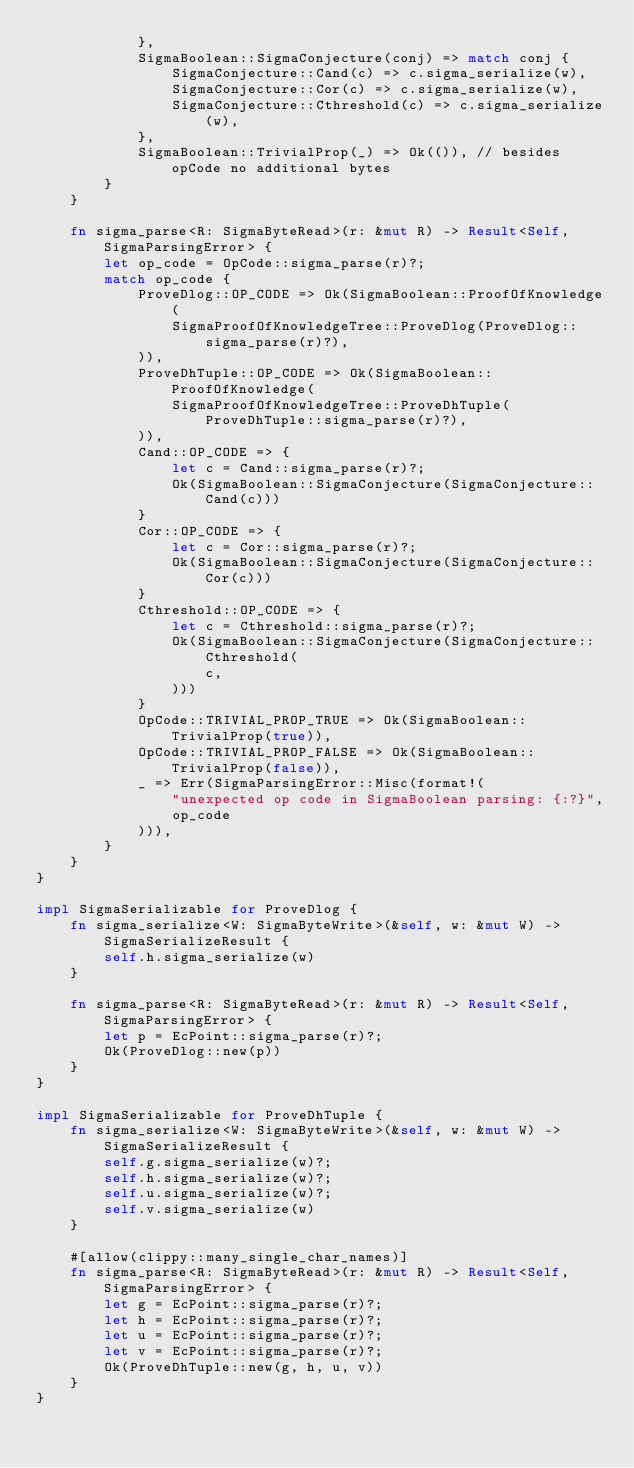<code> <loc_0><loc_0><loc_500><loc_500><_Rust_>            },
            SigmaBoolean::SigmaConjecture(conj) => match conj {
                SigmaConjecture::Cand(c) => c.sigma_serialize(w),
                SigmaConjecture::Cor(c) => c.sigma_serialize(w),
                SigmaConjecture::Cthreshold(c) => c.sigma_serialize(w),
            },
            SigmaBoolean::TrivialProp(_) => Ok(()), // besides opCode no additional bytes
        }
    }

    fn sigma_parse<R: SigmaByteRead>(r: &mut R) -> Result<Self, SigmaParsingError> {
        let op_code = OpCode::sigma_parse(r)?;
        match op_code {
            ProveDlog::OP_CODE => Ok(SigmaBoolean::ProofOfKnowledge(
                SigmaProofOfKnowledgeTree::ProveDlog(ProveDlog::sigma_parse(r)?),
            )),
            ProveDhTuple::OP_CODE => Ok(SigmaBoolean::ProofOfKnowledge(
                SigmaProofOfKnowledgeTree::ProveDhTuple(ProveDhTuple::sigma_parse(r)?),
            )),
            Cand::OP_CODE => {
                let c = Cand::sigma_parse(r)?;
                Ok(SigmaBoolean::SigmaConjecture(SigmaConjecture::Cand(c)))
            }
            Cor::OP_CODE => {
                let c = Cor::sigma_parse(r)?;
                Ok(SigmaBoolean::SigmaConjecture(SigmaConjecture::Cor(c)))
            }
            Cthreshold::OP_CODE => {
                let c = Cthreshold::sigma_parse(r)?;
                Ok(SigmaBoolean::SigmaConjecture(SigmaConjecture::Cthreshold(
                    c,
                )))
            }
            OpCode::TRIVIAL_PROP_TRUE => Ok(SigmaBoolean::TrivialProp(true)),
            OpCode::TRIVIAL_PROP_FALSE => Ok(SigmaBoolean::TrivialProp(false)),
            _ => Err(SigmaParsingError::Misc(format!(
                "unexpected op code in SigmaBoolean parsing: {:?}",
                op_code
            ))),
        }
    }
}

impl SigmaSerializable for ProveDlog {
    fn sigma_serialize<W: SigmaByteWrite>(&self, w: &mut W) -> SigmaSerializeResult {
        self.h.sigma_serialize(w)
    }

    fn sigma_parse<R: SigmaByteRead>(r: &mut R) -> Result<Self, SigmaParsingError> {
        let p = EcPoint::sigma_parse(r)?;
        Ok(ProveDlog::new(p))
    }
}

impl SigmaSerializable for ProveDhTuple {
    fn sigma_serialize<W: SigmaByteWrite>(&self, w: &mut W) -> SigmaSerializeResult {
        self.g.sigma_serialize(w)?;
        self.h.sigma_serialize(w)?;
        self.u.sigma_serialize(w)?;
        self.v.sigma_serialize(w)
    }

    #[allow(clippy::many_single_char_names)]
    fn sigma_parse<R: SigmaByteRead>(r: &mut R) -> Result<Self, SigmaParsingError> {
        let g = EcPoint::sigma_parse(r)?;
        let h = EcPoint::sigma_parse(r)?;
        let u = EcPoint::sigma_parse(r)?;
        let v = EcPoint::sigma_parse(r)?;
        Ok(ProveDhTuple::new(g, h, u, v))
    }
}
</code> 